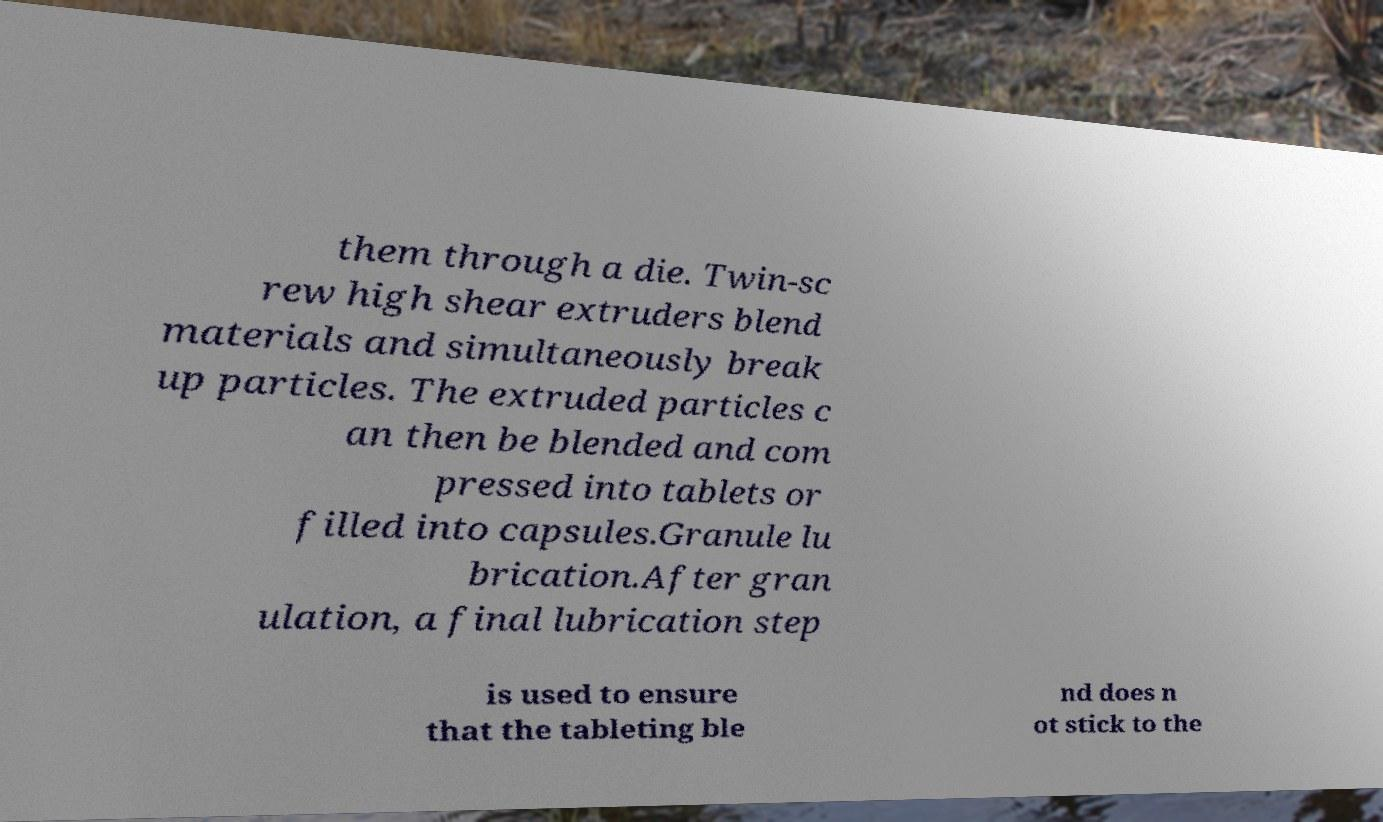I need the written content from this picture converted into text. Can you do that? them through a die. Twin-sc rew high shear extruders blend materials and simultaneously break up particles. The extruded particles c an then be blended and com pressed into tablets or filled into capsules.Granule lu brication.After gran ulation, a final lubrication step is used to ensure that the tableting ble nd does n ot stick to the 